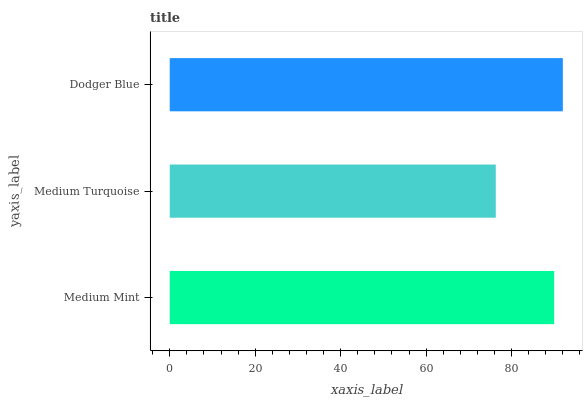Is Medium Turquoise the minimum?
Answer yes or no. Yes. Is Dodger Blue the maximum?
Answer yes or no. Yes. Is Dodger Blue the minimum?
Answer yes or no. No. Is Medium Turquoise the maximum?
Answer yes or no. No. Is Dodger Blue greater than Medium Turquoise?
Answer yes or no. Yes. Is Medium Turquoise less than Dodger Blue?
Answer yes or no. Yes. Is Medium Turquoise greater than Dodger Blue?
Answer yes or no. No. Is Dodger Blue less than Medium Turquoise?
Answer yes or no. No. Is Medium Mint the high median?
Answer yes or no. Yes. Is Medium Mint the low median?
Answer yes or no. Yes. Is Dodger Blue the high median?
Answer yes or no. No. Is Dodger Blue the low median?
Answer yes or no. No. 